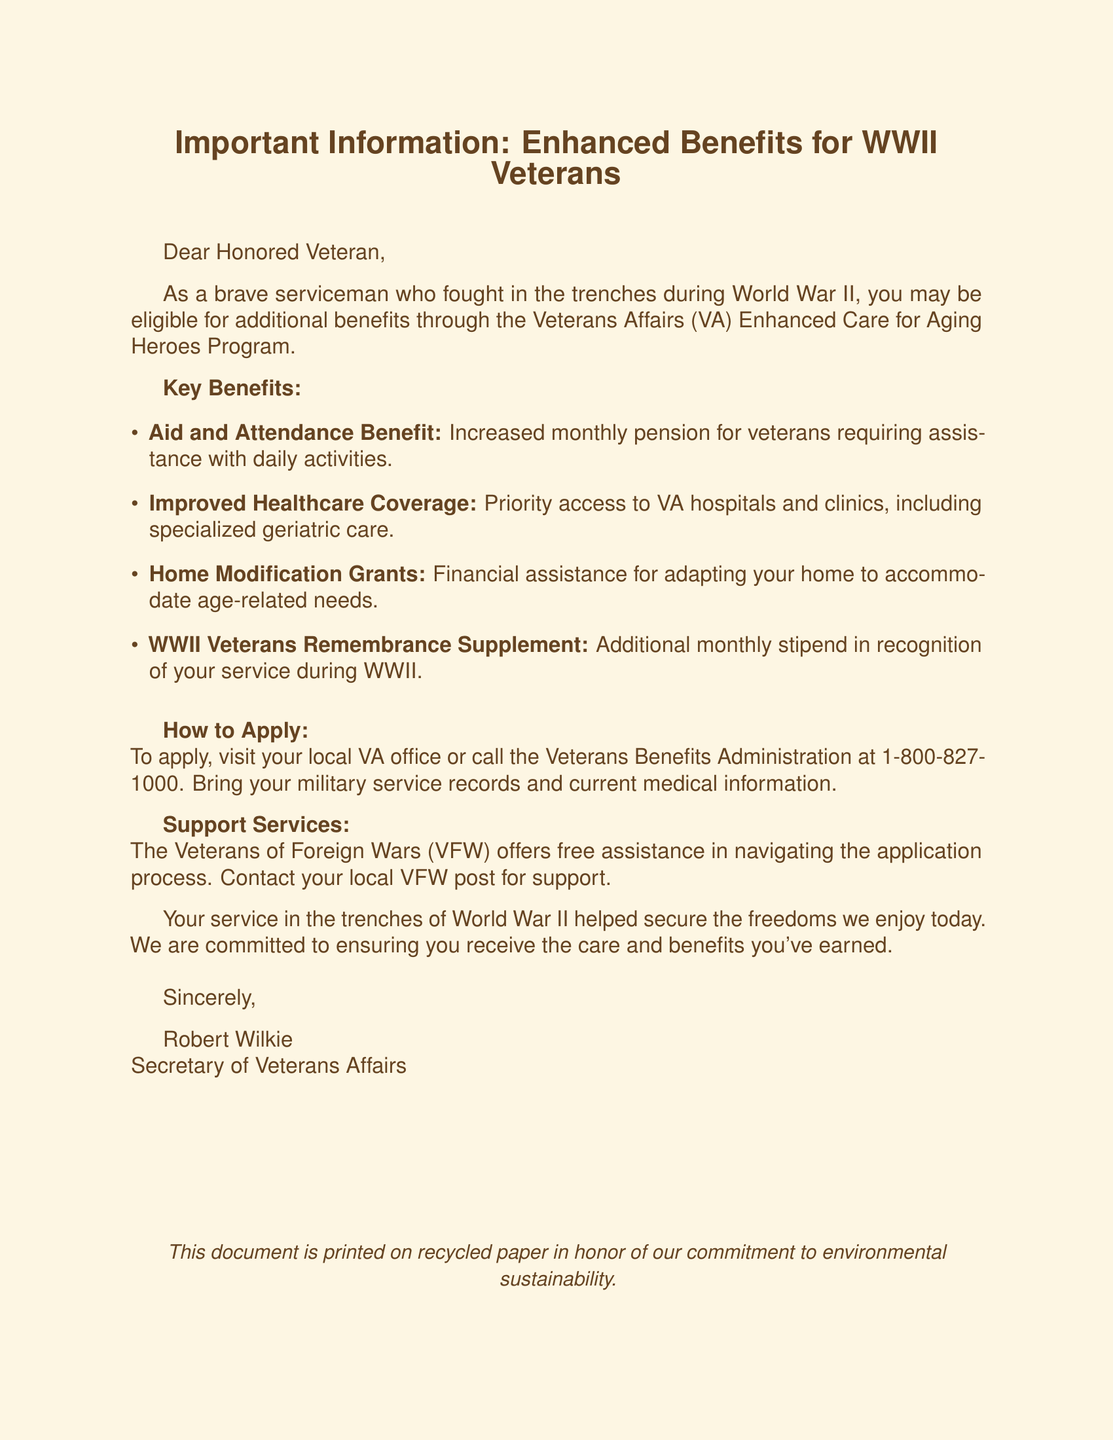What is the subject of the email? The subject of the email is specified at the beginning and is related to enhanced benefits for veterans.
Answer: Important Information: Enhanced Benefits for WWII Veterans Who is the salutation addressed to? The salutation is directed towards a specific audience, which is indicated in the greeting.
Answer: Honored Veteran What benefit provides financial assistance for home modifications? The document lists various benefits, one of which specifically helps with adapting homes for aging needs.
Answer: Home Modification Grants What is the phone number for the Veterans Benefits Administration? This information is included for veterans to inquire about the application process.
Answer: 1-800-827-1000 Which organization offers free assistance in the application process? The document notes organizations that provide support to veterans during the application process.
Answer: Veterans of Foreign Wars (VFW) What is required to apply for the benefits? The application process involves gathering specific documents before heading to the local VA office.
Answer: Military service records and current medical information What does the WWII Veterans Remembrance Supplement provide? This benefit recognizes the service of WWII veterans and offers additional financial support.
Answer: Additional monthly stipend What is the main purpose of this document? The document is conveying important information about available benefits for a particular group of veterans.
Answer: To inform about enhanced benefits for aging heroes 